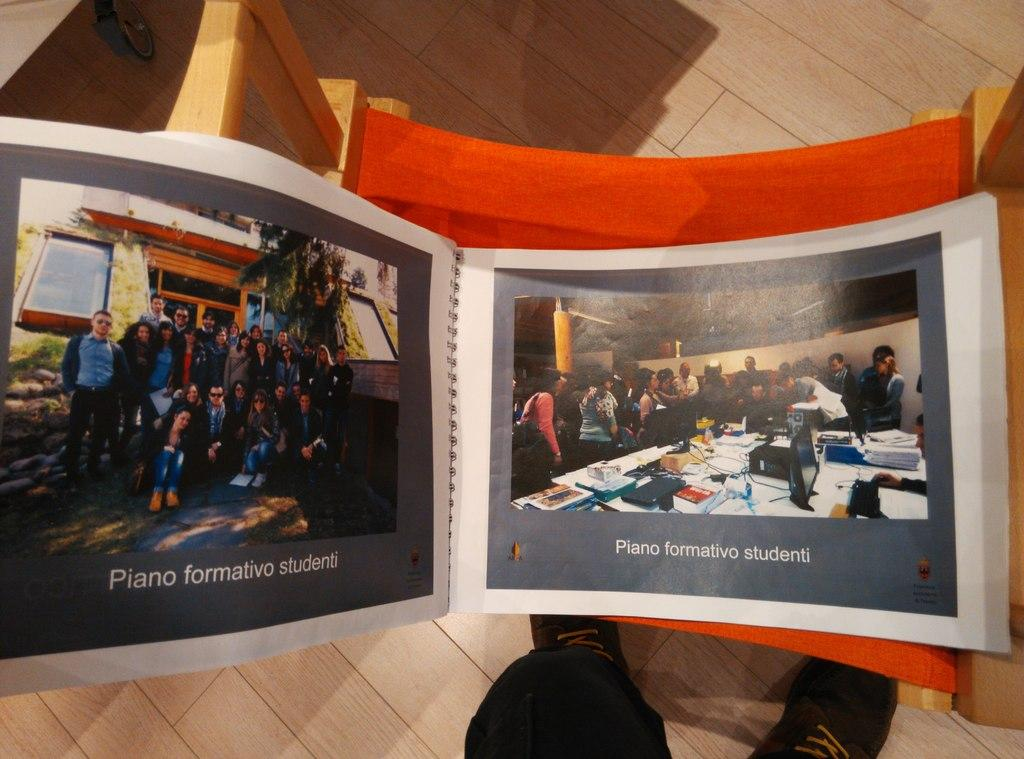<image>
Summarize the visual content of the image. Two color group pictures of Piano formativo studenti. 